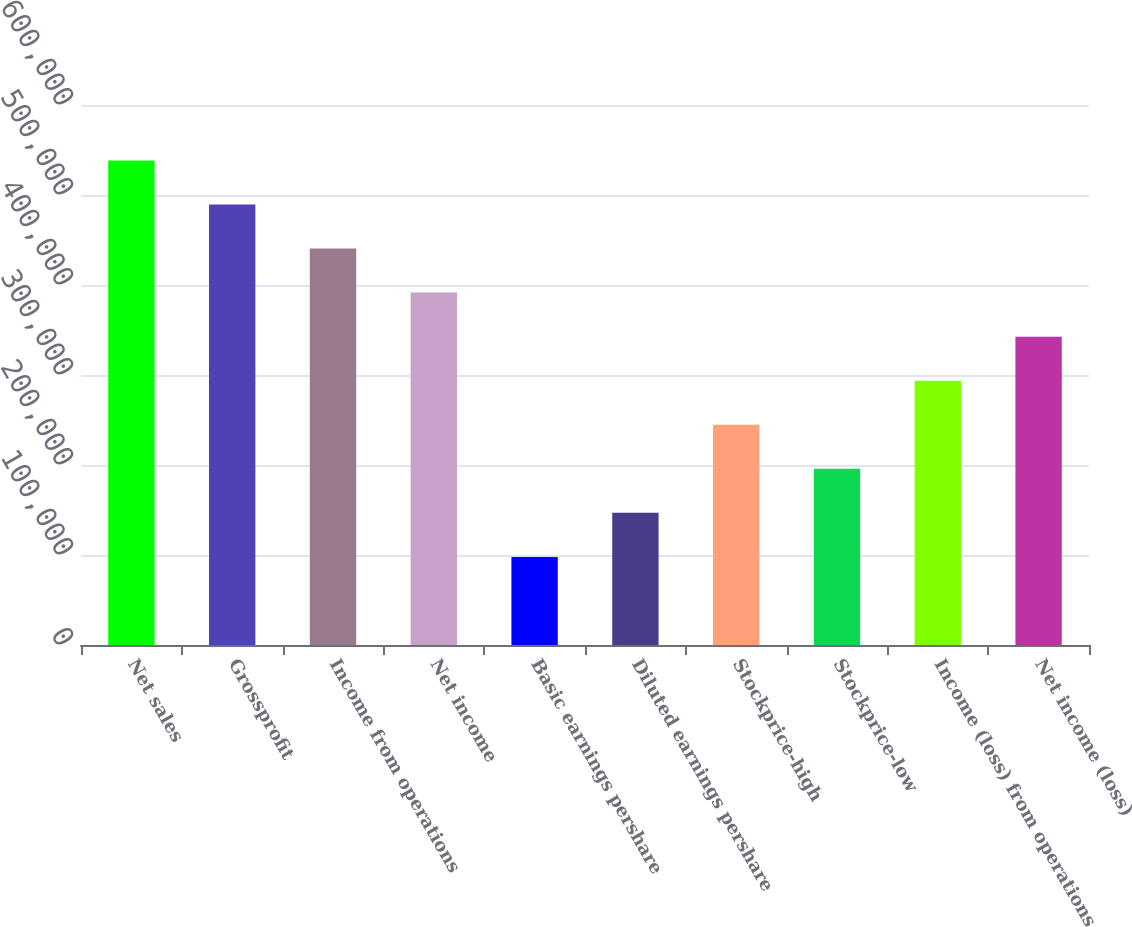<chart> <loc_0><loc_0><loc_500><loc_500><bar_chart><fcel>Net sales<fcel>Grossprofit<fcel>Income from operations<fcel>Net income<fcel>Basic earnings pershare<fcel>Diluted earnings pershare<fcel>Stockprice-high<fcel>Stockprice-low<fcel>Income (loss) from operations<fcel>Net income (loss)<nl><fcel>538381<fcel>489437<fcel>440493<fcel>391550<fcel>97887.4<fcel>146831<fcel>244719<fcel>195775<fcel>293662<fcel>342606<nl></chart> 